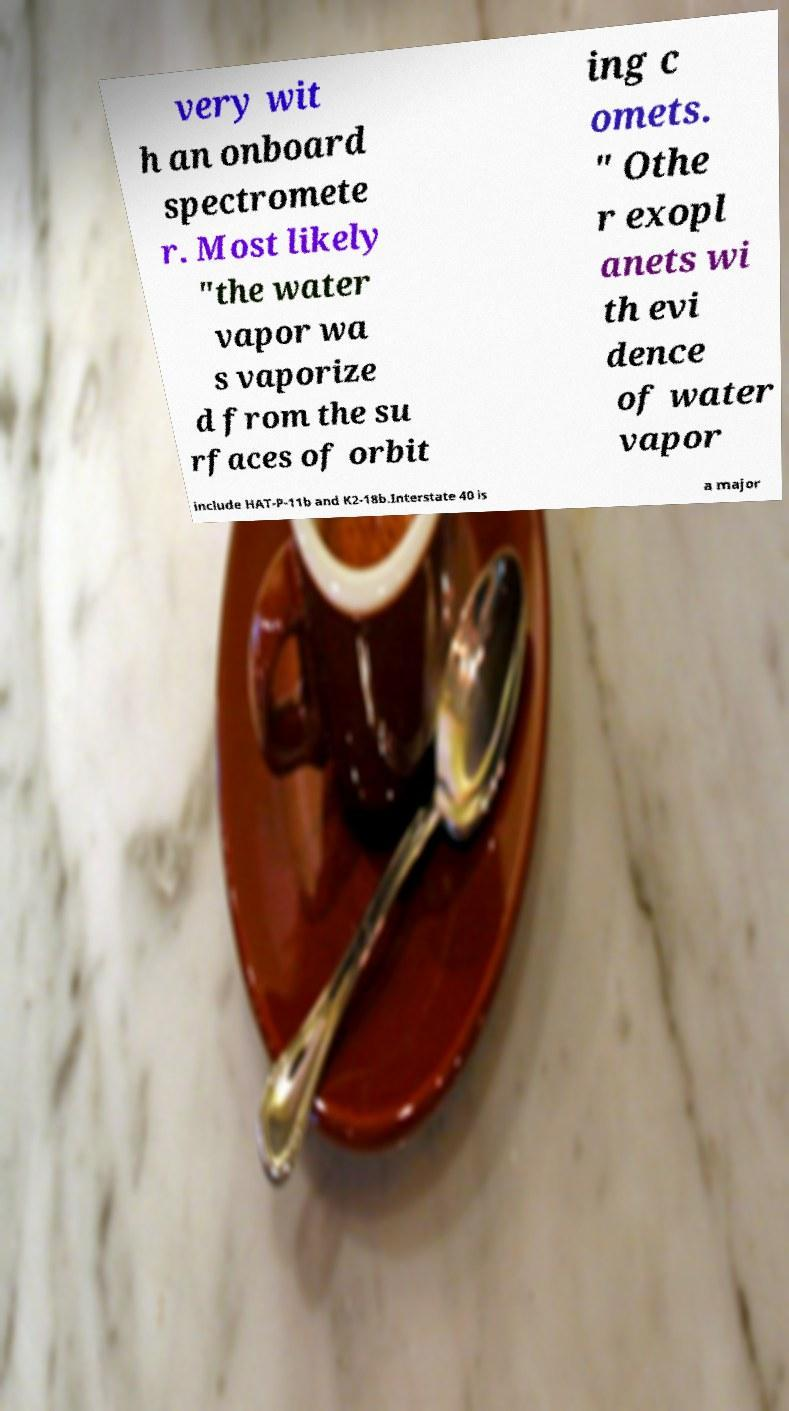There's text embedded in this image that I need extracted. Can you transcribe it verbatim? very wit h an onboard spectromete r. Most likely "the water vapor wa s vaporize d from the su rfaces of orbit ing c omets. " Othe r exopl anets wi th evi dence of water vapor include HAT-P-11b and K2-18b.Interstate 40 is a major 